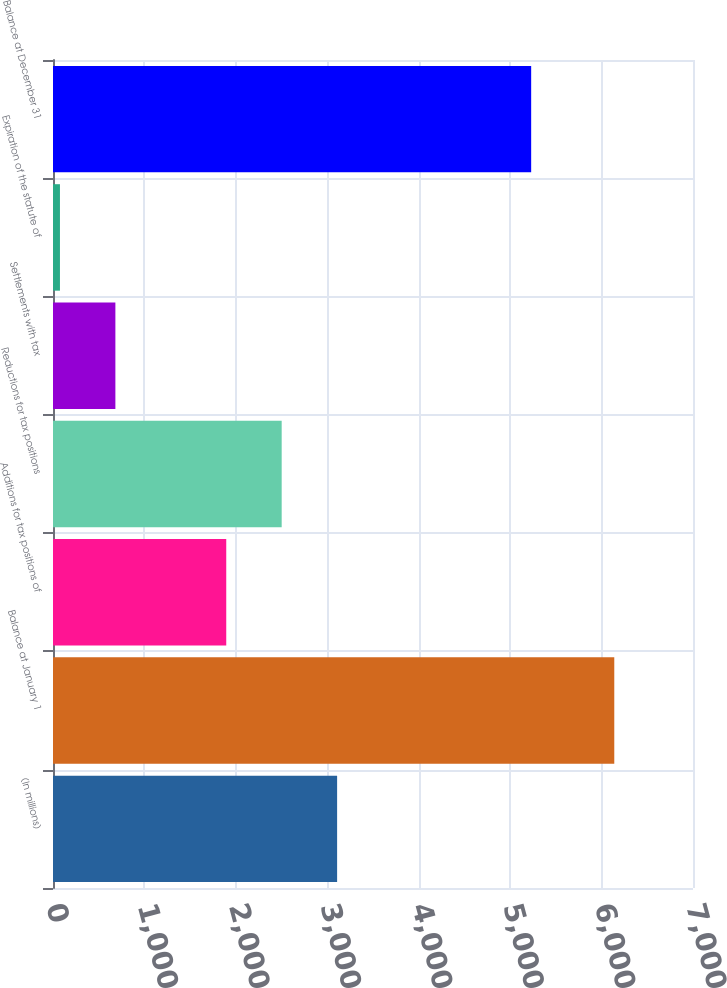Convert chart to OTSL. <chart><loc_0><loc_0><loc_500><loc_500><bar_chart><fcel>(In millions)<fcel>Balance at January 1<fcel>Additions for tax positions of<fcel>Reductions for tax positions<fcel>Settlements with tax<fcel>Expiration of the statute of<fcel>Balance at December 31<nl><fcel>3107.5<fcel>6139<fcel>1894.9<fcel>2501.2<fcel>682.3<fcel>76<fcel>5230<nl></chart> 